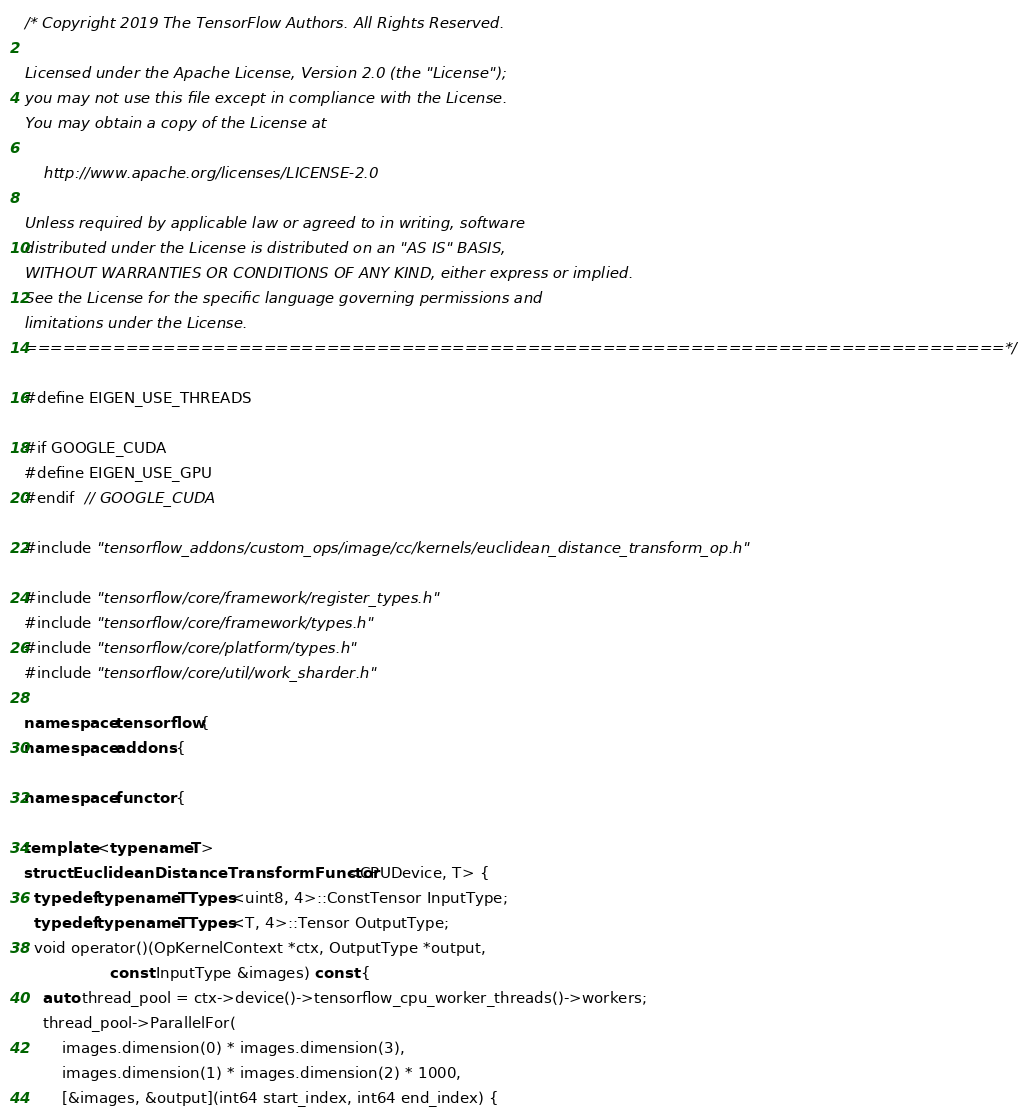Convert code to text. <code><loc_0><loc_0><loc_500><loc_500><_C++_>/* Copyright 2019 The TensorFlow Authors. All Rights Reserved.

Licensed under the Apache License, Version 2.0 (the "License");
you may not use this file except in compliance with the License.
You may obtain a copy of the License at

    http://www.apache.org/licenses/LICENSE-2.0

Unless required by applicable law or agreed to in writing, software
distributed under the License is distributed on an "AS IS" BASIS,
WITHOUT WARRANTIES OR CONDITIONS OF ANY KIND, either express or implied.
See the License for the specific language governing permissions and
limitations under the License.
==============================================================================*/

#define EIGEN_USE_THREADS

#if GOOGLE_CUDA
#define EIGEN_USE_GPU
#endif  // GOOGLE_CUDA

#include "tensorflow_addons/custom_ops/image/cc/kernels/euclidean_distance_transform_op.h"

#include "tensorflow/core/framework/register_types.h"
#include "tensorflow/core/framework/types.h"
#include "tensorflow/core/platform/types.h"
#include "tensorflow/core/util/work_sharder.h"

namespace tensorflow {
namespace addons {

namespace functor {

template <typename T>
struct EuclideanDistanceTransformFunctor<CPUDevice, T> {
  typedef typename TTypes<uint8, 4>::ConstTensor InputType;
  typedef typename TTypes<T, 4>::Tensor OutputType;
  void operator()(OpKernelContext *ctx, OutputType *output,
                  const InputType &images) const {
    auto thread_pool = ctx->device()->tensorflow_cpu_worker_threads()->workers;
    thread_pool->ParallelFor(
        images.dimension(0) * images.dimension(3),
        images.dimension(1) * images.dimension(2) * 1000,
        [&images, &output](int64 start_index, int64 end_index) {</code> 